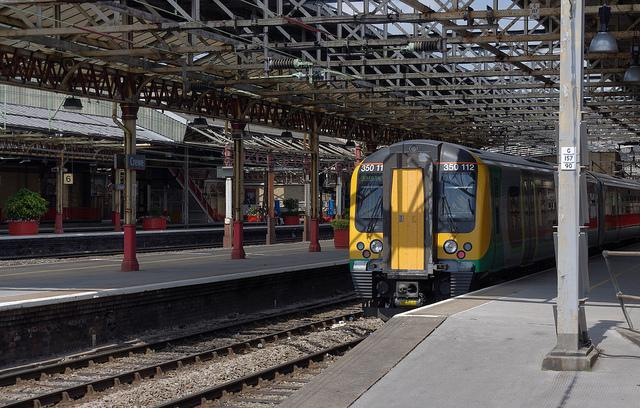Which numbers are fully visible on both the top left and top right of the front of the bus?

Choices:
A) 350
B) 399
C) 810
D) 220 350 